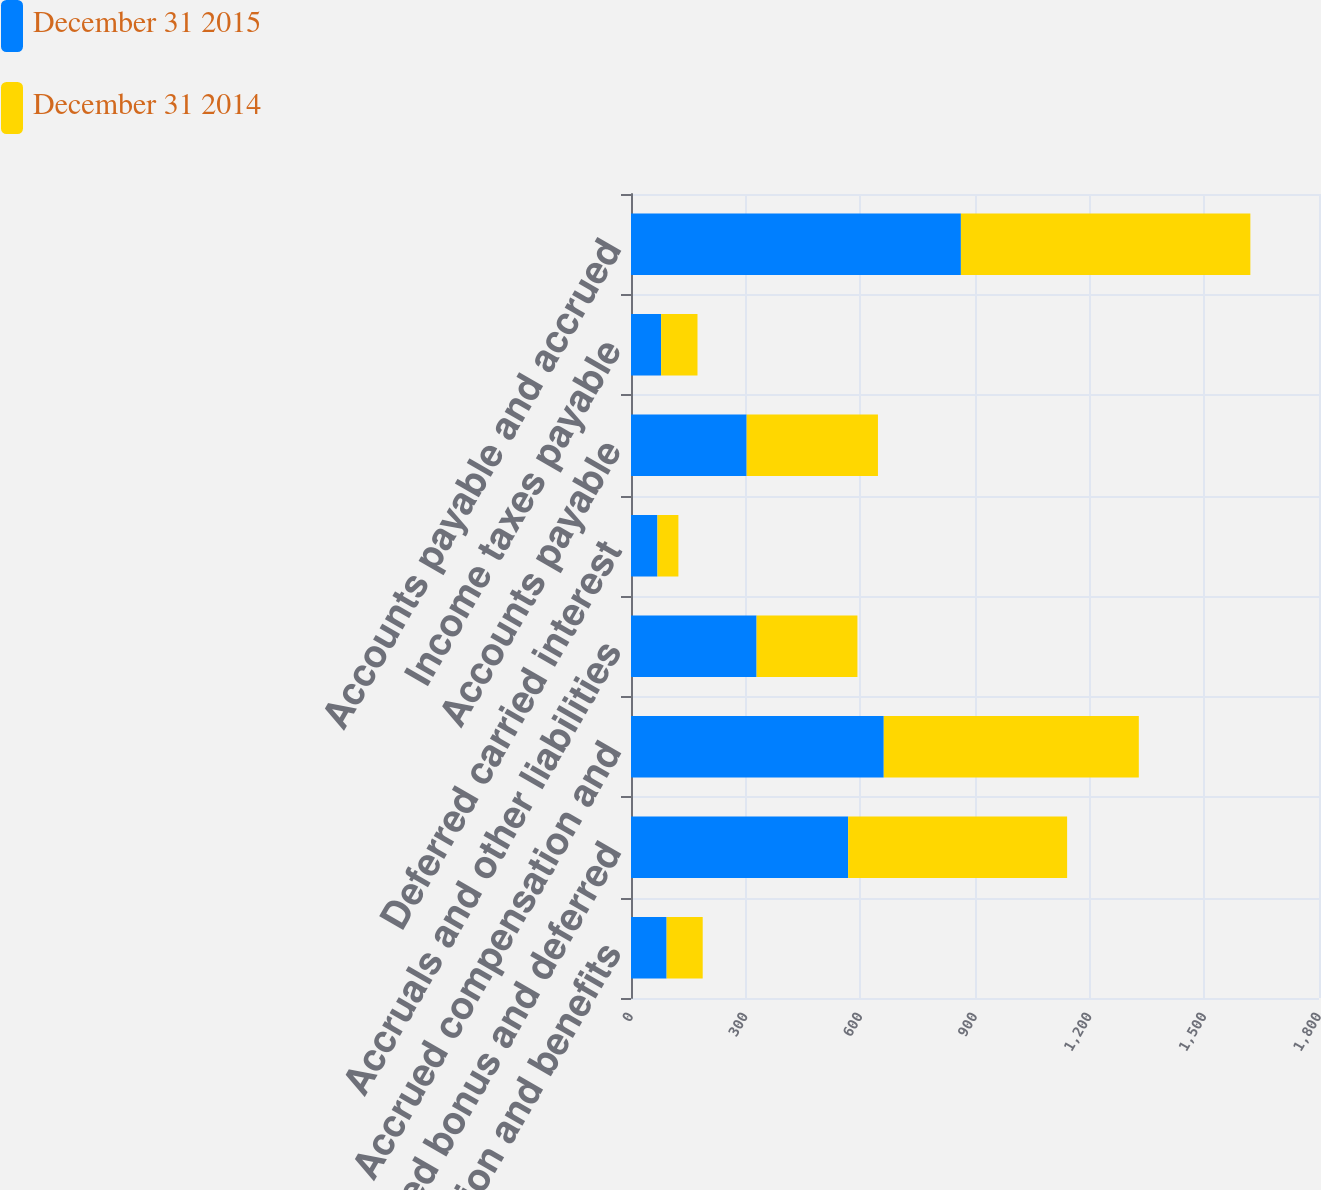<chart> <loc_0><loc_0><loc_500><loc_500><stacked_bar_chart><ecel><fcel>Compensation and benefits<fcel>Accrued bonus and deferred<fcel>Accrued compensation and<fcel>Accruals and other liabilities<fcel>Deferred carried interest<fcel>Accounts payable<fcel>Income taxes payable<fcel>Accounts payable and accrued<nl><fcel>December 31 2015<fcel>93.2<fcel>568.1<fcel>661.3<fcel>328.6<fcel>69.2<fcel>302.6<fcel>78.8<fcel>863.1<nl><fcel>December 31 2014<fcel>94.4<fcel>572.9<fcel>667.3<fcel>263.8<fcel>54.8<fcel>343.5<fcel>95.2<fcel>757.3<nl></chart> 